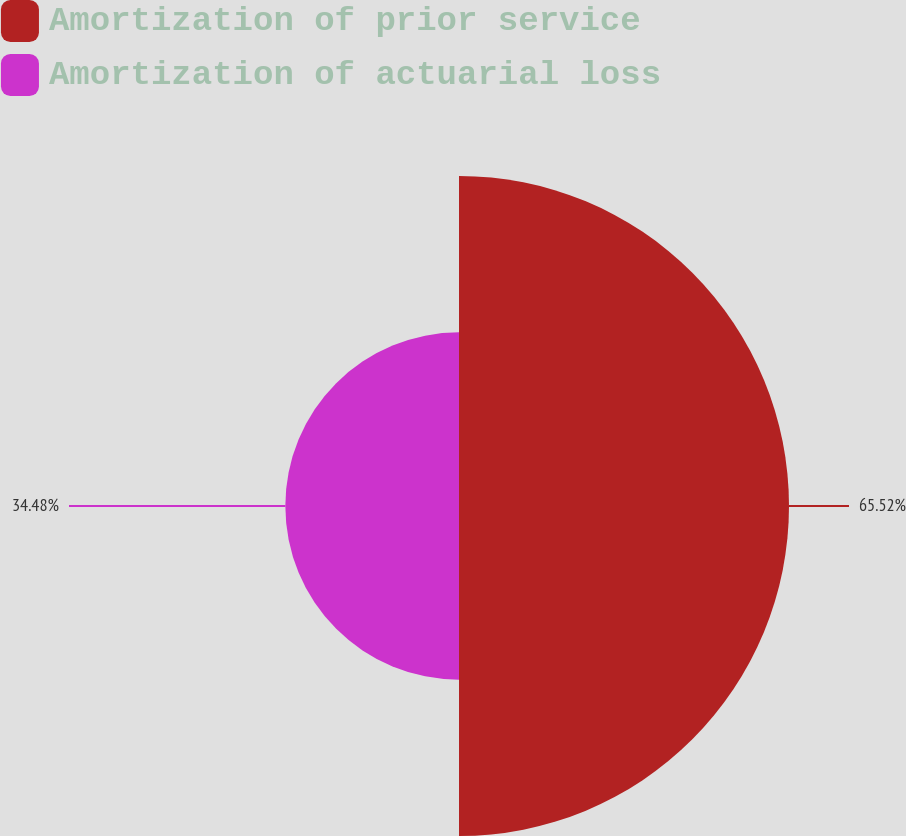Convert chart. <chart><loc_0><loc_0><loc_500><loc_500><pie_chart><fcel>Amortization of prior service<fcel>Amortization of actuarial loss<nl><fcel>65.52%<fcel>34.48%<nl></chart> 